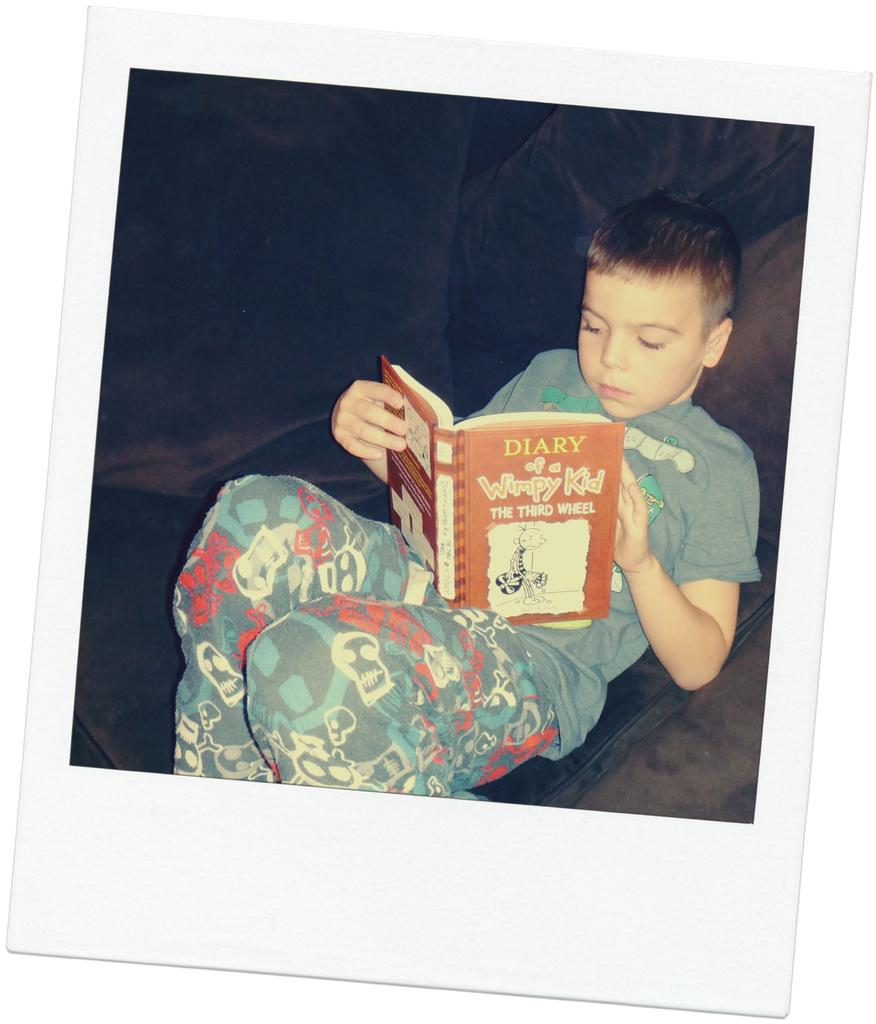<image>
Provide a brief description of the given image. A young boy reads "Diary of a Wimpy Kid - The Third Wheel." 